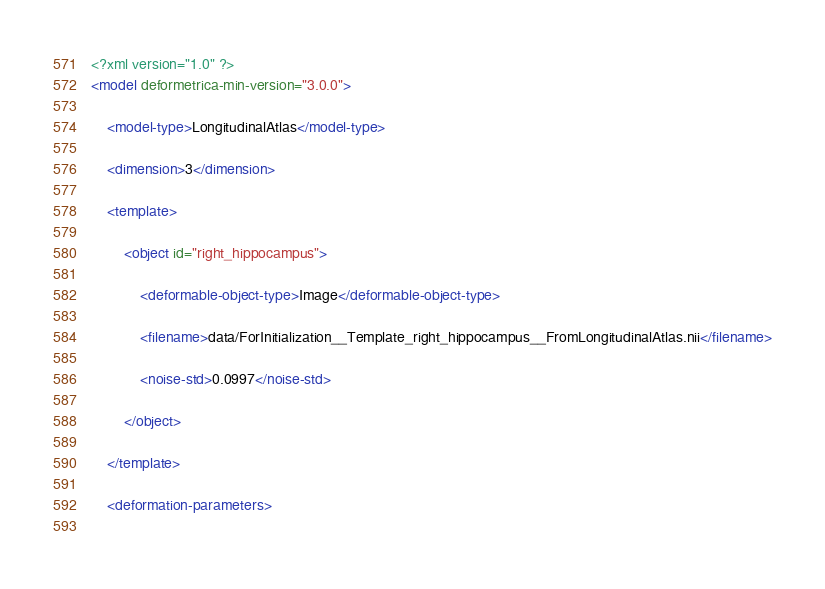<code> <loc_0><loc_0><loc_500><loc_500><_XML_><?xml version="1.0" ?>
<model deformetrica-min-version="3.0.0">
	    
	<model-type>LongitudinalAtlas</model-type>
	    
	<dimension>3</dimension>
	    
	<template>
		        
		<object id="right_hippocampus">
			            
			<deformable-object-type>Image</deformable-object-type>
			            
			<filename>data/ForInitialization__Template_right_hippocampus__FromLongitudinalAtlas.nii</filename>
			            
			<noise-std>0.0997</noise-std>
			        
		</object>
		    
	</template>
	    
	<deformation-parameters>
		        </code> 